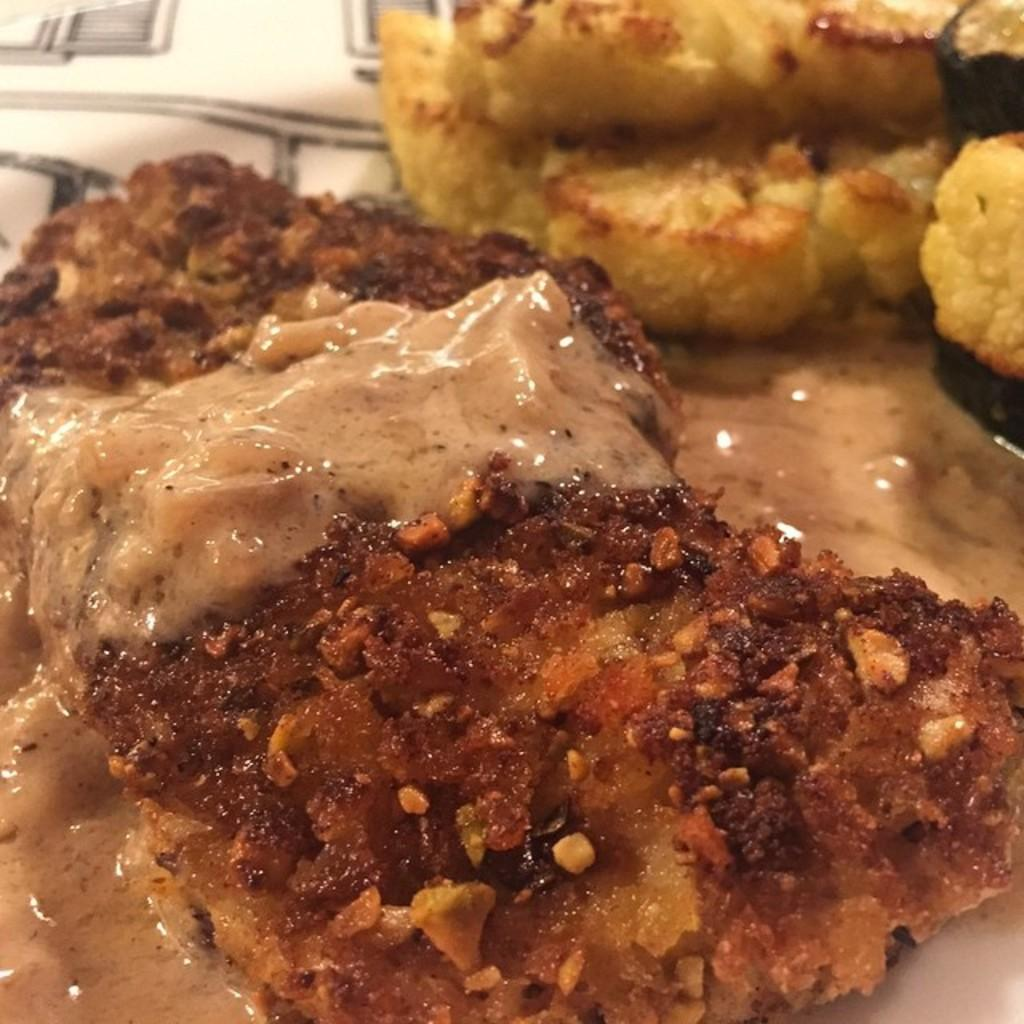What can be seen in the image? There is food in the image. What type of coal is being used to fuel the bear's belief in the image? There is no coal, bear, or belief present in the image; it only features food. 